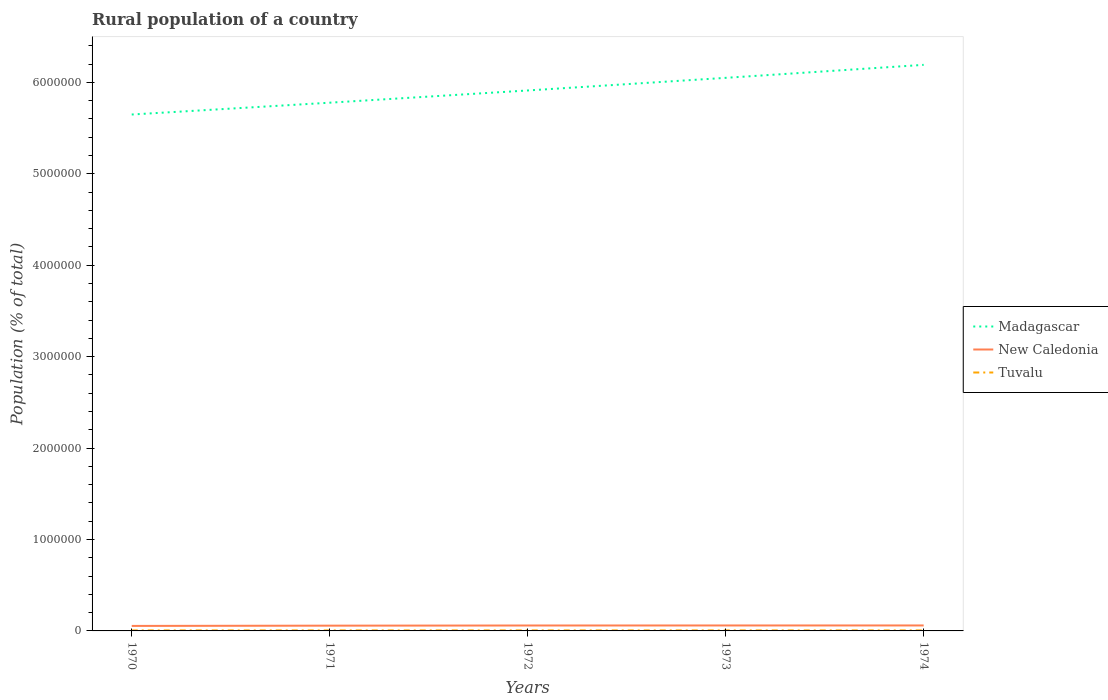Does the line corresponding to Madagascar intersect with the line corresponding to New Caledonia?
Make the answer very short. No. Across all years, what is the maximum rural population in New Caledonia?
Provide a succinct answer. 5.46e+04. What is the total rural population in New Caledonia in the graph?
Your answer should be very brief. -406. What is the difference between the highest and the second highest rural population in New Caledonia?
Your response must be concise. 5140. What is the difference between the highest and the lowest rural population in Tuvalu?
Your answer should be very brief. 3. Is the rural population in Madagascar strictly greater than the rural population in New Caledonia over the years?
Keep it short and to the point. No. How many lines are there?
Ensure brevity in your answer.  3. How many years are there in the graph?
Offer a terse response. 5. What is the difference between two consecutive major ticks on the Y-axis?
Keep it short and to the point. 1.00e+06. Where does the legend appear in the graph?
Offer a very short reply. Center right. How are the legend labels stacked?
Offer a terse response. Vertical. What is the title of the graph?
Your answer should be compact. Rural population of a country. What is the label or title of the Y-axis?
Make the answer very short. Population (% of total). What is the Population (% of total) in Madagascar in 1970?
Offer a very short reply. 5.65e+06. What is the Population (% of total) in New Caledonia in 1970?
Your response must be concise. 5.46e+04. What is the Population (% of total) in Tuvalu in 1970?
Your answer should be compact. 5685. What is the Population (% of total) in Madagascar in 1971?
Give a very brief answer. 5.78e+06. What is the Population (% of total) of New Caledonia in 1971?
Offer a very short reply. 5.76e+04. What is the Population (% of total) of Tuvalu in 1971?
Keep it short and to the point. 5698. What is the Population (% of total) in Madagascar in 1972?
Offer a very short reply. 5.91e+06. What is the Population (% of total) of New Caledonia in 1972?
Your answer should be compact. 5.92e+04. What is the Population (% of total) of Tuvalu in 1972?
Offer a very short reply. 5706. What is the Population (% of total) in Madagascar in 1973?
Your answer should be very brief. 6.05e+06. What is the Population (% of total) of New Caledonia in 1973?
Offer a very short reply. 5.96e+04. What is the Population (% of total) of Tuvalu in 1973?
Your response must be concise. 5711. What is the Population (% of total) in Madagascar in 1974?
Make the answer very short. 6.19e+06. What is the Population (% of total) in New Caledonia in 1974?
Keep it short and to the point. 5.98e+04. What is the Population (% of total) in Tuvalu in 1974?
Offer a very short reply. 5710. Across all years, what is the maximum Population (% of total) of Madagascar?
Make the answer very short. 6.19e+06. Across all years, what is the maximum Population (% of total) in New Caledonia?
Your answer should be very brief. 5.98e+04. Across all years, what is the maximum Population (% of total) in Tuvalu?
Give a very brief answer. 5711. Across all years, what is the minimum Population (% of total) of Madagascar?
Offer a very short reply. 5.65e+06. Across all years, what is the minimum Population (% of total) in New Caledonia?
Make the answer very short. 5.46e+04. Across all years, what is the minimum Population (% of total) of Tuvalu?
Make the answer very short. 5685. What is the total Population (% of total) in Madagascar in the graph?
Offer a very short reply. 2.96e+07. What is the total Population (% of total) in New Caledonia in the graph?
Your response must be concise. 2.91e+05. What is the total Population (% of total) in Tuvalu in the graph?
Provide a short and direct response. 2.85e+04. What is the difference between the Population (% of total) in Madagascar in 1970 and that in 1971?
Make the answer very short. -1.29e+05. What is the difference between the Population (% of total) in New Caledonia in 1970 and that in 1971?
Provide a succinct answer. -2954. What is the difference between the Population (% of total) of Madagascar in 1970 and that in 1972?
Provide a succinct answer. -2.63e+05. What is the difference between the Population (% of total) of New Caledonia in 1970 and that in 1972?
Provide a succinct answer. -4602. What is the difference between the Population (% of total) of Tuvalu in 1970 and that in 1972?
Offer a terse response. -21. What is the difference between the Population (% of total) of Madagascar in 1970 and that in 1973?
Provide a succinct answer. -4.01e+05. What is the difference between the Population (% of total) of New Caledonia in 1970 and that in 1973?
Offer a terse response. -5008. What is the difference between the Population (% of total) of Tuvalu in 1970 and that in 1973?
Offer a terse response. -26. What is the difference between the Population (% of total) in Madagascar in 1970 and that in 1974?
Make the answer very short. -5.43e+05. What is the difference between the Population (% of total) in New Caledonia in 1970 and that in 1974?
Your answer should be compact. -5140. What is the difference between the Population (% of total) of Madagascar in 1971 and that in 1972?
Offer a terse response. -1.34e+05. What is the difference between the Population (% of total) in New Caledonia in 1971 and that in 1972?
Your answer should be very brief. -1648. What is the difference between the Population (% of total) in Madagascar in 1971 and that in 1973?
Your answer should be very brief. -2.72e+05. What is the difference between the Population (% of total) of New Caledonia in 1971 and that in 1973?
Offer a terse response. -2054. What is the difference between the Population (% of total) of Madagascar in 1971 and that in 1974?
Offer a very short reply. -4.14e+05. What is the difference between the Population (% of total) of New Caledonia in 1971 and that in 1974?
Ensure brevity in your answer.  -2186. What is the difference between the Population (% of total) in Tuvalu in 1971 and that in 1974?
Provide a succinct answer. -12. What is the difference between the Population (% of total) in Madagascar in 1972 and that in 1973?
Ensure brevity in your answer.  -1.38e+05. What is the difference between the Population (% of total) of New Caledonia in 1972 and that in 1973?
Offer a very short reply. -406. What is the difference between the Population (% of total) in Madagascar in 1972 and that in 1974?
Ensure brevity in your answer.  -2.80e+05. What is the difference between the Population (% of total) of New Caledonia in 1972 and that in 1974?
Ensure brevity in your answer.  -538. What is the difference between the Population (% of total) of Madagascar in 1973 and that in 1974?
Your response must be concise. -1.42e+05. What is the difference between the Population (% of total) of New Caledonia in 1973 and that in 1974?
Offer a very short reply. -132. What is the difference between the Population (% of total) of Tuvalu in 1973 and that in 1974?
Offer a terse response. 1. What is the difference between the Population (% of total) in Madagascar in 1970 and the Population (% of total) in New Caledonia in 1971?
Ensure brevity in your answer.  5.59e+06. What is the difference between the Population (% of total) of Madagascar in 1970 and the Population (% of total) of Tuvalu in 1971?
Provide a short and direct response. 5.64e+06. What is the difference between the Population (% of total) of New Caledonia in 1970 and the Population (% of total) of Tuvalu in 1971?
Ensure brevity in your answer.  4.89e+04. What is the difference between the Population (% of total) in Madagascar in 1970 and the Population (% of total) in New Caledonia in 1972?
Make the answer very short. 5.59e+06. What is the difference between the Population (% of total) in Madagascar in 1970 and the Population (% of total) in Tuvalu in 1972?
Keep it short and to the point. 5.64e+06. What is the difference between the Population (% of total) in New Caledonia in 1970 and the Population (% of total) in Tuvalu in 1972?
Your answer should be compact. 4.89e+04. What is the difference between the Population (% of total) of Madagascar in 1970 and the Population (% of total) of New Caledonia in 1973?
Provide a short and direct response. 5.59e+06. What is the difference between the Population (% of total) of Madagascar in 1970 and the Population (% of total) of Tuvalu in 1973?
Offer a terse response. 5.64e+06. What is the difference between the Population (% of total) in New Caledonia in 1970 and the Population (% of total) in Tuvalu in 1973?
Your answer should be very brief. 4.89e+04. What is the difference between the Population (% of total) of Madagascar in 1970 and the Population (% of total) of New Caledonia in 1974?
Your answer should be compact. 5.59e+06. What is the difference between the Population (% of total) in Madagascar in 1970 and the Population (% of total) in Tuvalu in 1974?
Your response must be concise. 5.64e+06. What is the difference between the Population (% of total) of New Caledonia in 1970 and the Population (% of total) of Tuvalu in 1974?
Give a very brief answer. 4.89e+04. What is the difference between the Population (% of total) of Madagascar in 1971 and the Population (% of total) of New Caledonia in 1972?
Keep it short and to the point. 5.72e+06. What is the difference between the Population (% of total) in Madagascar in 1971 and the Population (% of total) in Tuvalu in 1972?
Ensure brevity in your answer.  5.77e+06. What is the difference between the Population (% of total) of New Caledonia in 1971 and the Population (% of total) of Tuvalu in 1972?
Your response must be concise. 5.19e+04. What is the difference between the Population (% of total) of Madagascar in 1971 and the Population (% of total) of New Caledonia in 1973?
Make the answer very short. 5.72e+06. What is the difference between the Population (% of total) in Madagascar in 1971 and the Population (% of total) in Tuvalu in 1973?
Ensure brevity in your answer.  5.77e+06. What is the difference between the Population (% of total) in New Caledonia in 1971 and the Population (% of total) in Tuvalu in 1973?
Keep it short and to the point. 5.19e+04. What is the difference between the Population (% of total) in Madagascar in 1971 and the Population (% of total) in New Caledonia in 1974?
Offer a terse response. 5.72e+06. What is the difference between the Population (% of total) of Madagascar in 1971 and the Population (% of total) of Tuvalu in 1974?
Provide a succinct answer. 5.77e+06. What is the difference between the Population (% of total) in New Caledonia in 1971 and the Population (% of total) in Tuvalu in 1974?
Give a very brief answer. 5.19e+04. What is the difference between the Population (% of total) of Madagascar in 1972 and the Population (% of total) of New Caledonia in 1973?
Provide a succinct answer. 5.85e+06. What is the difference between the Population (% of total) of Madagascar in 1972 and the Population (% of total) of Tuvalu in 1973?
Ensure brevity in your answer.  5.91e+06. What is the difference between the Population (% of total) of New Caledonia in 1972 and the Population (% of total) of Tuvalu in 1973?
Your answer should be very brief. 5.35e+04. What is the difference between the Population (% of total) in Madagascar in 1972 and the Population (% of total) in New Caledonia in 1974?
Your answer should be very brief. 5.85e+06. What is the difference between the Population (% of total) of Madagascar in 1972 and the Population (% of total) of Tuvalu in 1974?
Give a very brief answer. 5.91e+06. What is the difference between the Population (% of total) of New Caledonia in 1972 and the Population (% of total) of Tuvalu in 1974?
Provide a short and direct response. 5.35e+04. What is the difference between the Population (% of total) of Madagascar in 1973 and the Population (% of total) of New Caledonia in 1974?
Your response must be concise. 5.99e+06. What is the difference between the Population (% of total) in Madagascar in 1973 and the Population (% of total) in Tuvalu in 1974?
Offer a terse response. 6.04e+06. What is the difference between the Population (% of total) in New Caledonia in 1973 and the Population (% of total) in Tuvalu in 1974?
Provide a succinct answer. 5.39e+04. What is the average Population (% of total) of Madagascar per year?
Ensure brevity in your answer.  5.92e+06. What is the average Population (% of total) in New Caledonia per year?
Provide a succinct answer. 5.82e+04. What is the average Population (% of total) of Tuvalu per year?
Offer a terse response. 5702. In the year 1970, what is the difference between the Population (% of total) in Madagascar and Population (% of total) in New Caledonia?
Offer a terse response. 5.59e+06. In the year 1970, what is the difference between the Population (% of total) of Madagascar and Population (% of total) of Tuvalu?
Provide a short and direct response. 5.64e+06. In the year 1970, what is the difference between the Population (% of total) of New Caledonia and Population (% of total) of Tuvalu?
Make the answer very short. 4.89e+04. In the year 1971, what is the difference between the Population (% of total) of Madagascar and Population (% of total) of New Caledonia?
Your answer should be very brief. 5.72e+06. In the year 1971, what is the difference between the Population (% of total) in Madagascar and Population (% of total) in Tuvalu?
Offer a very short reply. 5.77e+06. In the year 1971, what is the difference between the Population (% of total) of New Caledonia and Population (% of total) of Tuvalu?
Your answer should be compact. 5.19e+04. In the year 1972, what is the difference between the Population (% of total) of Madagascar and Population (% of total) of New Caledonia?
Offer a very short reply. 5.85e+06. In the year 1972, what is the difference between the Population (% of total) in Madagascar and Population (% of total) in Tuvalu?
Give a very brief answer. 5.91e+06. In the year 1972, what is the difference between the Population (% of total) in New Caledonia and Population (% of total) in Tuvalu?
Your response must be concise. 5.35e+04. In the year 1973, what is the difference between the Population (% of total) in Madagascar and Population (% of total) in New Caledonia?
Offer a terse response. 5.99e+06. In the year 1973, what is the difference between the Population (% of total) in Madagascar and Population (% of total) in Tuvalu?
Provide a succinct answer. 6.04e+06. In the year 1973, what is the difference between the Population (% of total) of New Caledonia and Population (% of total) of Tuvalu?
Offer a terse response. 5.39e+04. In the year 1974, what is the difference between the Population (% of total) in Madagascar and Population (% of total) in New Caledonia?
Provide a succinct answer. 6.13e+06. In the year 1974, what is the difference between the Population (% of total) in Madagascar and Population (% of total) in Tuvalu?
Your answer should be compact. 6.19e+06. In the year 1974, what is the difference between the Population (% of total) in New Caledonia and Population (% of total) in Tuvalu?
Your answer should be very brief. 5.40e+04. What is the ratio of the Population (% of total) of Madagascar in 1970 to that in 1971?
Make the answer very short. 0.98. What is the ratio of the Population (% of total) of New Caledonia in 1970 to that in 1971?
Provide a short and direct response. 0.95. What is the ratio of the Population (% of total) of Madagascar in 1970 to that in 1972?
Offer a terse response. 0.96. What is the ratio of the Population (% of total) of New Caledonia in 1970 to that in 1972?
Provide a short and direct response. 0.92. What is the ratio of the Population (% of total) of Madagascar in 1970 to that in 1973?
Keep it short and to the point. 0.93. What is the ratio of the Population (% of total) of New Caledonia in 1970 to that in 1973?
Give a very brief answer. 0.92. What is the ratio of the Population (% of total) of Madagascar in 1970 to that in 1974?
Make the answer very short. 0.91. What is the ratio of the Population (% of total) of New Caledonia in 1970 to that in 1974?
Offer a very short reply. 0.91. What is the ratio of the Population (% of total) in Madagascar in 1971 to that in 1972?
Offer a very short reply. 0.98. What is the ratio of the Population (% of total) of New Caledonia in 1971 to that in 1972?
Your response must be concise. 0.97. What is the ratio of the Population (% of total) in Tuvalu in 1971 to that in 1972?
Offer a terse response. 1. What is the ratio of the Population (% of total) in Madagascar in 1971 to that in 1973?
Provide a succinct answer. 0.96. What is the ratio of the Population (% of total) of New Caledonia in 1971 to that in 1973?
Offer a very short reply. 0.97. What is the ratio of the Population (% of total) of Madagascar in 1971 to that in 1974?
Make the answer very short. 0.93. What is the ratio of the Population (% of total) of New Caledonia in 1971 to that in 1974?
Make the answer very short. 0.96. What is the ratio of the Population (% of total) of Madagascar in 1972 to that in 1973?
Your answer should be very brief. 0.98. What is the ratio of the Population (% of total) in New Caledonia in 1972 to that in 1973?
Offer a very short reply. 0.99. What is the ratio of the Population (% of total) in Madagascar in 1972 to that in 1974?
Give a very brief answer. 0.95. What is the ratio of the Population (% of total) in Madagascar in 1973 to that in 1974?
Your answer should be compact. 0.98. What is the ratio of the Population (% of total) in New Caledonia in 1973 to that in 1974?
Make the answer very short. 1. What is the ratio of the Population (% of total) in Tuvalu in 1973 to that in 1974?
Provide a short and direct response. 1. What is the difference between the highest and the second highest Population (% of total) of Madagascar?
Your answer should be very brief. 1.42e+05. What is the difference between the highest and the second highest Population (% of total) of New Caledonia?
Offer a terse response. 132. What is the difference between the highest and the second highest Population (% of total) in Tuvalu?
Make the answer very short. 1. What is the difference between the highest and the lowest Population (% of total) in Madagascar?
Your response must be concise. 5.43e+05. What is the difference between the highest and the lowest Population (% of total) of New Caledonia?
Your response must be concise. 5140. 